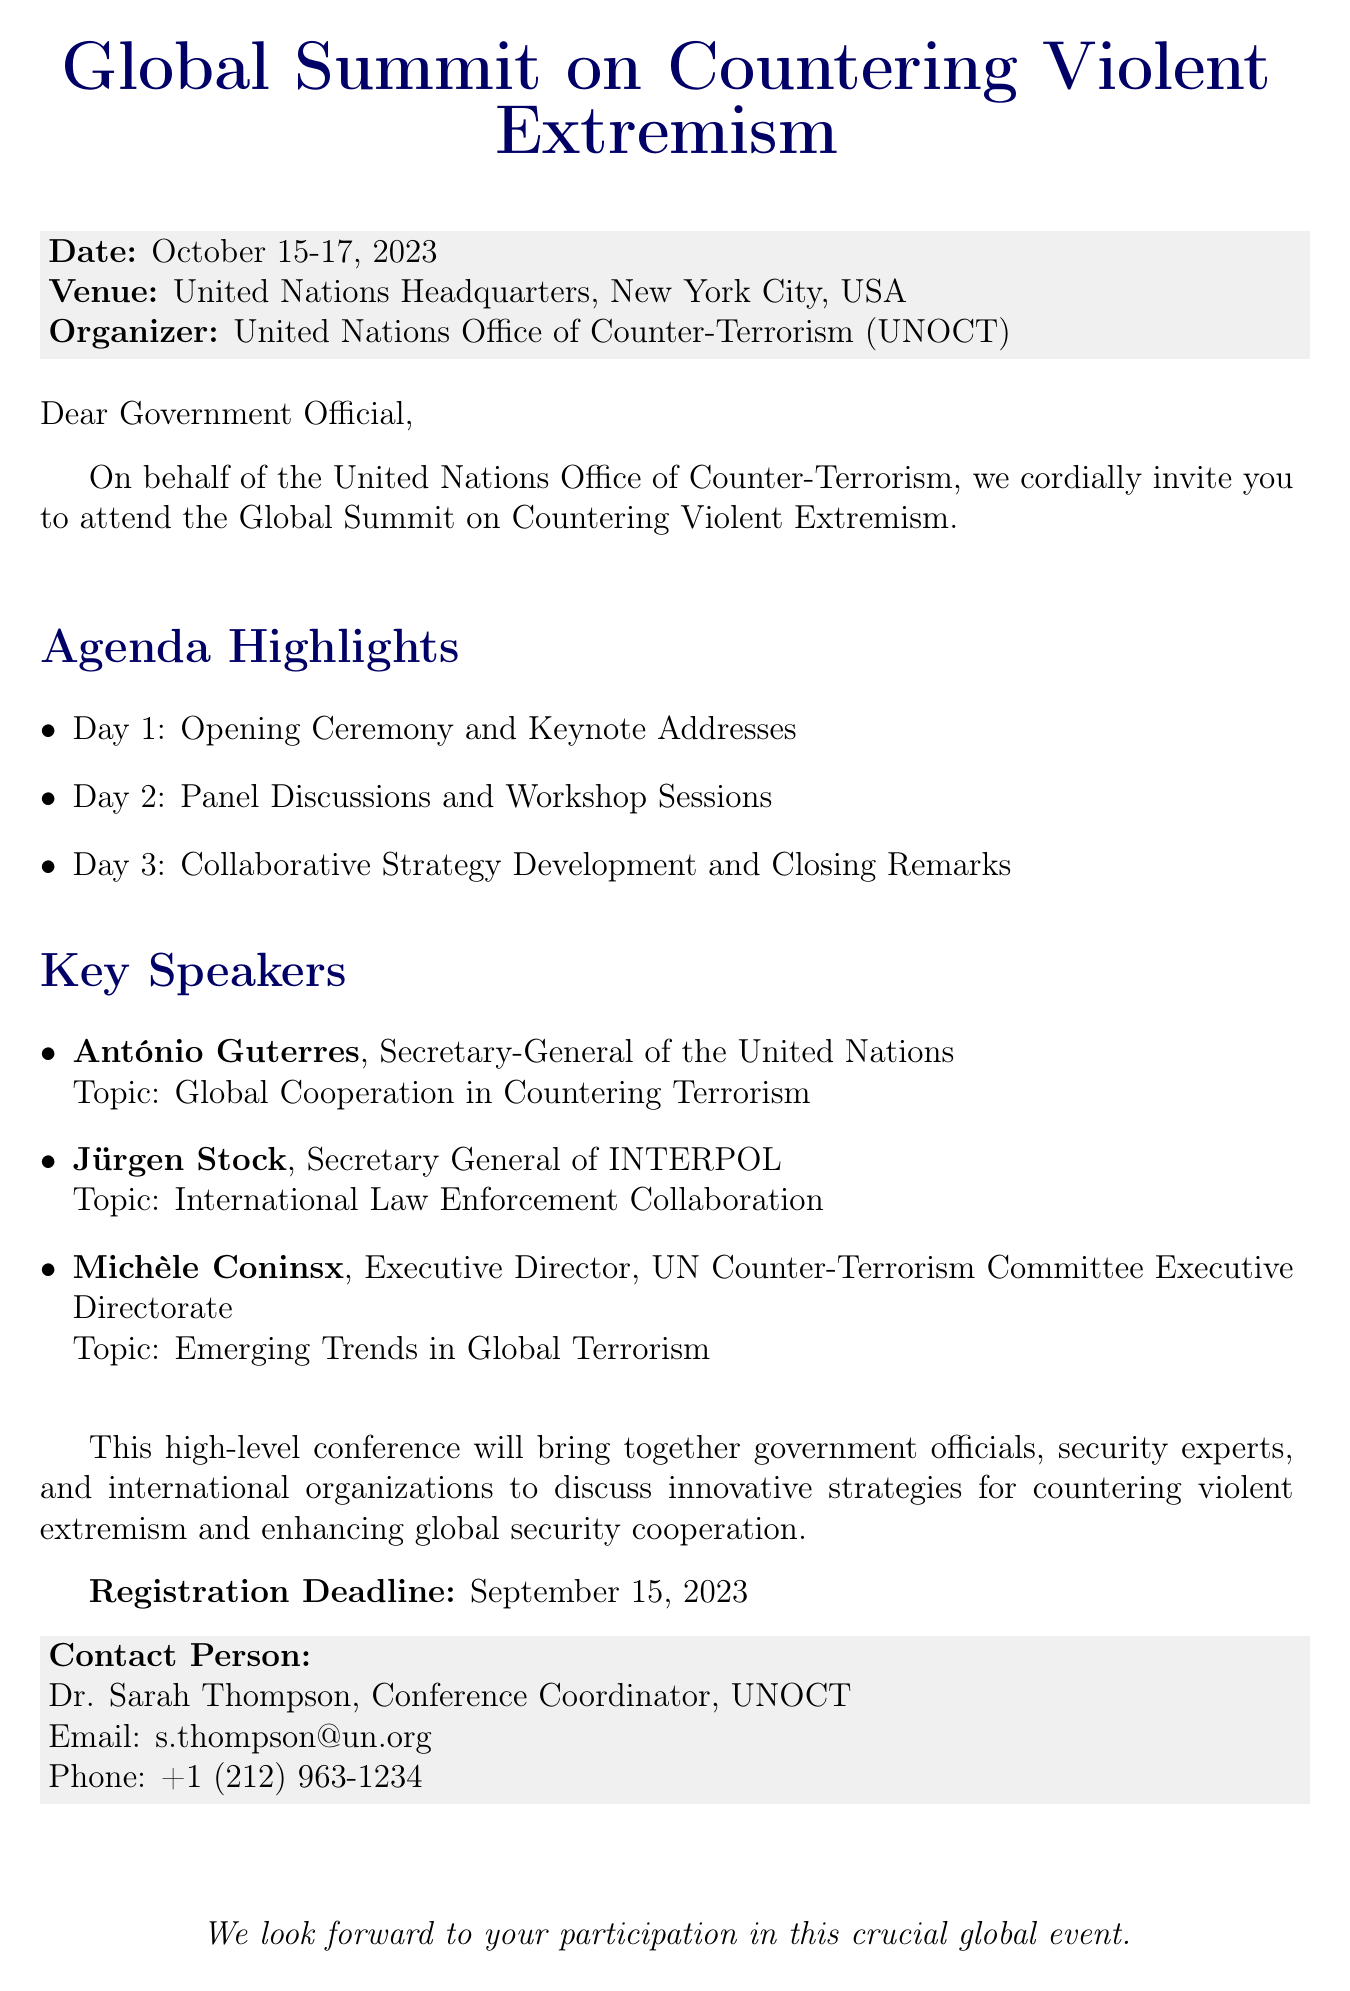What is the name of the conference? The document specifies the name of the conference as "Global Summit on Countering Violent Extremism."
Answer: Global Summit on Countering Violent Extremism When will the conference take place? The document lists the dates of the conference as October 15-17, 2023.
Answer: October 15-17, 2023 Where is the venue of the conference? The venue mentioned in the document is the "United Nations Headquarters, New York City, USA."
Answer: United Nations Headquarters, New York City, USA Who is the contact person for the conference? The document identifies Dr. Sarah Thompson as the contact person for the conference.
Answer: Dr. Sarah Thompson What is the registration deadline? The document states that the registration deadline is September 15, 2023.
Answer: September 15, 2023 What is a key topic addressed by António Guterres? The document notes that António Guterres will address "Global Cooperation in Countering Terrorism."
Answer: Global Cooperation in Countering Terrorism How many days will the conference span? The conference is mentioned to span three days, from October 15-17, 2023.
Answer: Three days What kind of sessions are included on Day 2 of the conference? The document indicates that Day 2 will include "Panel Discussions and Workshop Sessions."
Answer: Panel Discussions and Workshop Sessions What is the purpose of this conference? The document states that the conference aims to discuss innovative strategies for countering violent extremism and enhancing global security cooperation.
Answer: Discuss innovative strategies for countering violent extremism and enhancing global security cooperation 